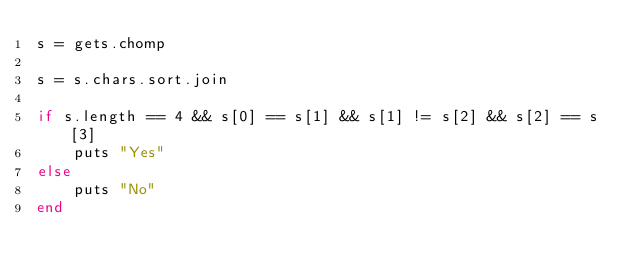Convert code to text. <code><loc_0><loc_0><loc_500><loc_500><_Ruby_>s = gets.chomp

s = s.chars.sort.join

if s.length == 4 && s[0] == s[1] && s[1] != s[2] && s[2] == s[3]
    puts "Yes"
else
    puts "No"
end
</code> 